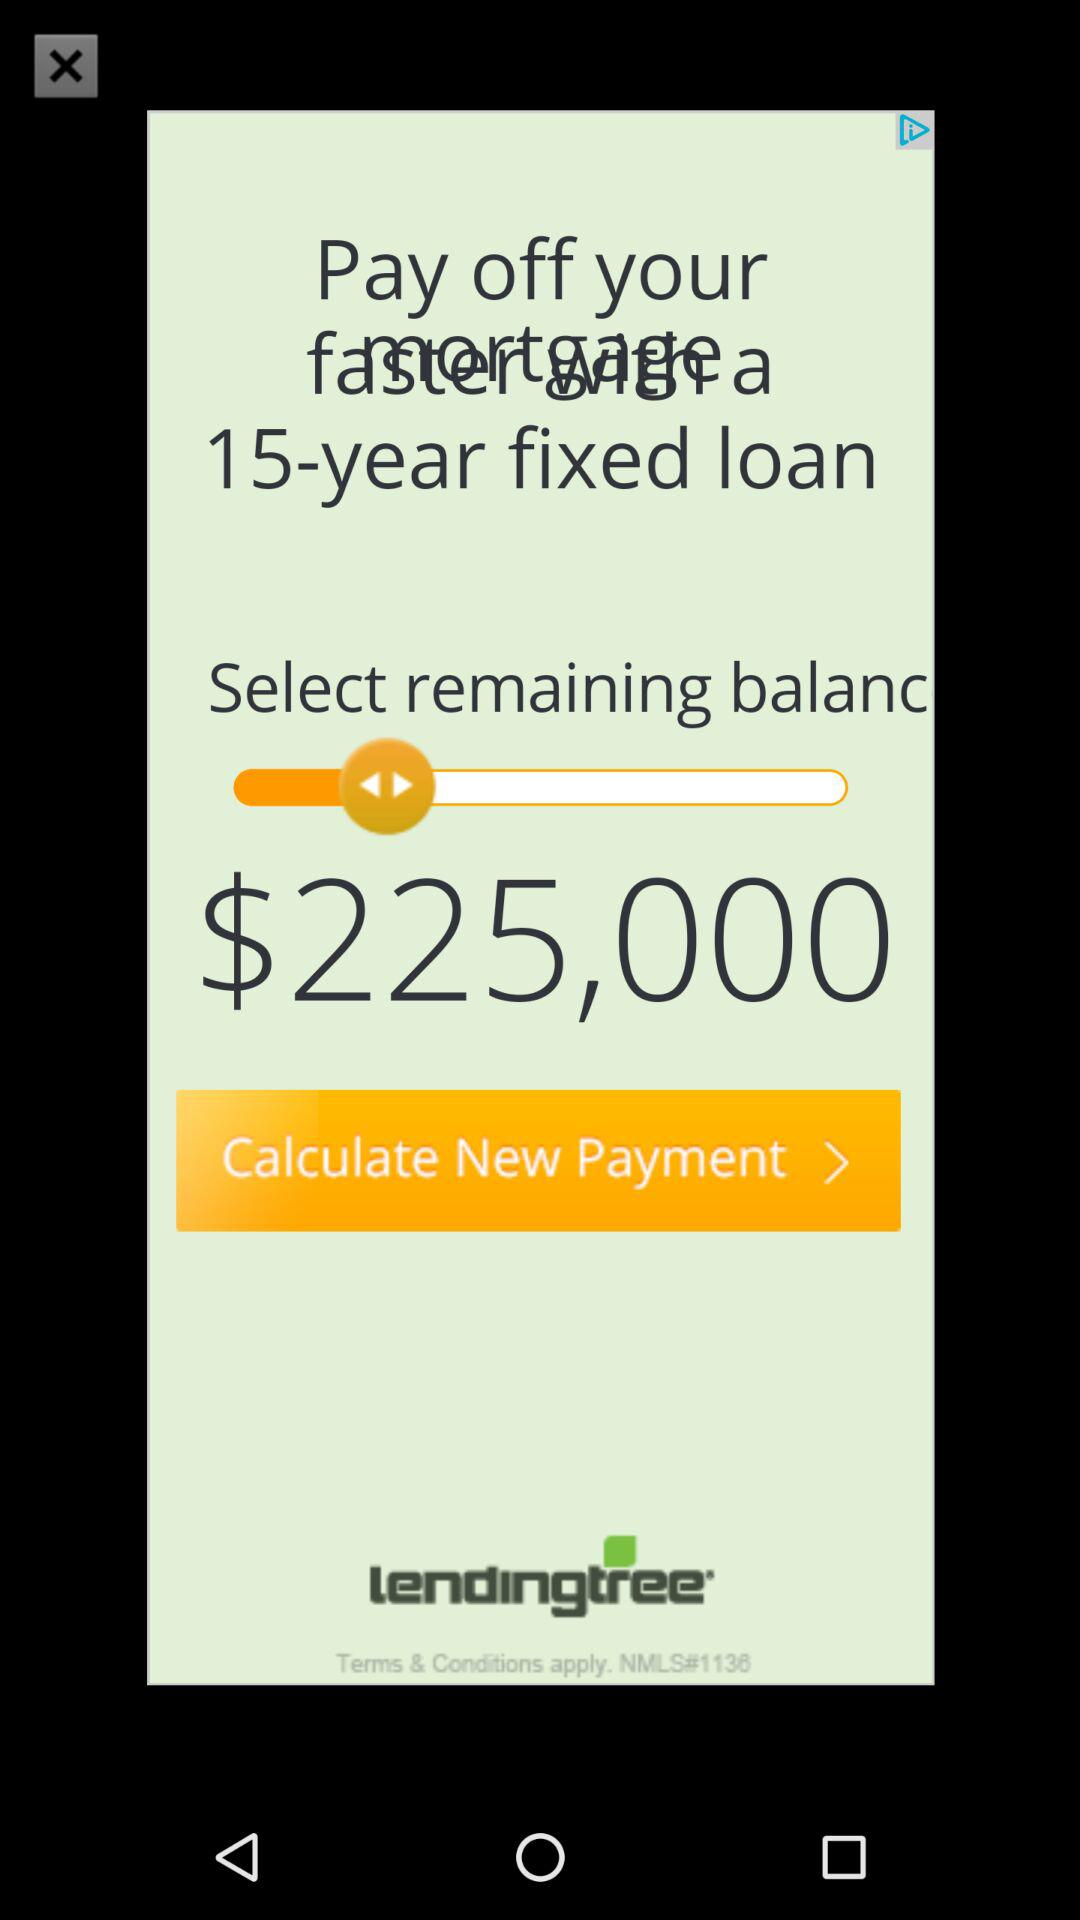How much more does the user need to pay off their loan?
Answer the question using a single word or phrase. $225,000 